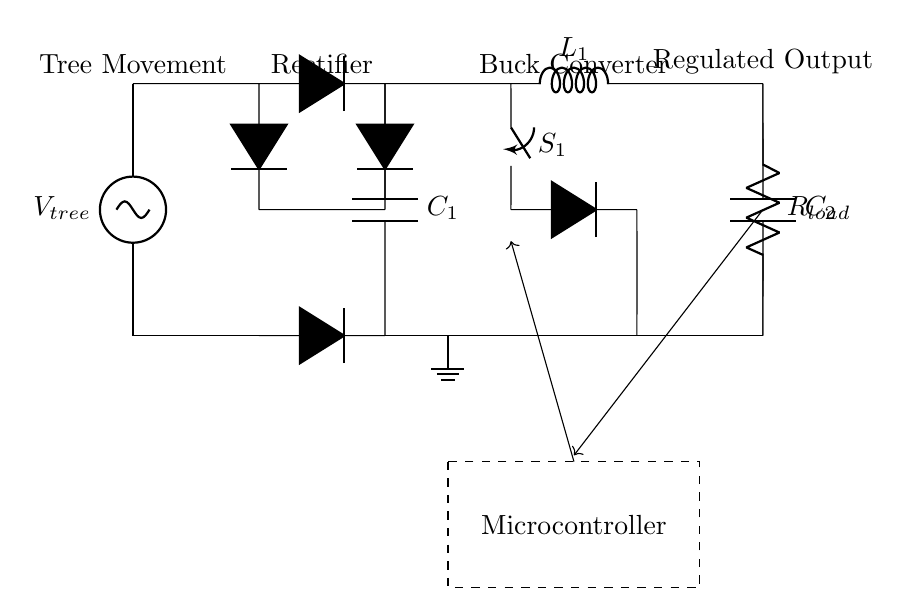What is the input source in this circuit? The input source is labeled as V tree, which indicates it is the voltage generated from tree movement.
Answer: V tree What type of components are used for rectification? The rectification in this circuit is done using diodes, which are marked with D, indicating they are diode components.
Answer: Diodes What is the purpose of capacitor C1? Capacitor C1 smooths the output from the rectifier by filtering out voltage fluctuations, providing a more stable power supply for the buck converter.
Answer: Smoothing How many diodes are present in the rectifier section? There are four diodes in the rectifier section as indicated by the four D symbols shown in that area of the circuit.
Answer: Four What component is used to convert voltage levels in this circuit? The buck converter section, consisting of an inductor and switch, is specifically used to step down voltage levels in this circuit.
Answer: Buck converter What role does the microcontroller play in this circuit? The microcontroller's role is to control the switching operation and provide feedback to regulate the output voltage effectively.
Answer: Control How is the system grounded in this circuit? The grounding is shown by a ground symbol connected to the bottom node of the circuit at point zero volts.
Answer: Ground symbol 